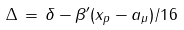<formula> <loc_0><loc_0><loc_500><loc_500>\Delta \, = \, \delta - \beta ^ { \prime } ( x _ { p } - a _ { \mu } ) / 1 6</formula> 